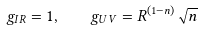Convert formula to latex. <formula><loc_0><loc_0><loc_500><loc_500>g _ { I R } = 1 , \quad g _ { U V } = R ^ { ( 1 - n ) } \sqrt { n }</formula> 